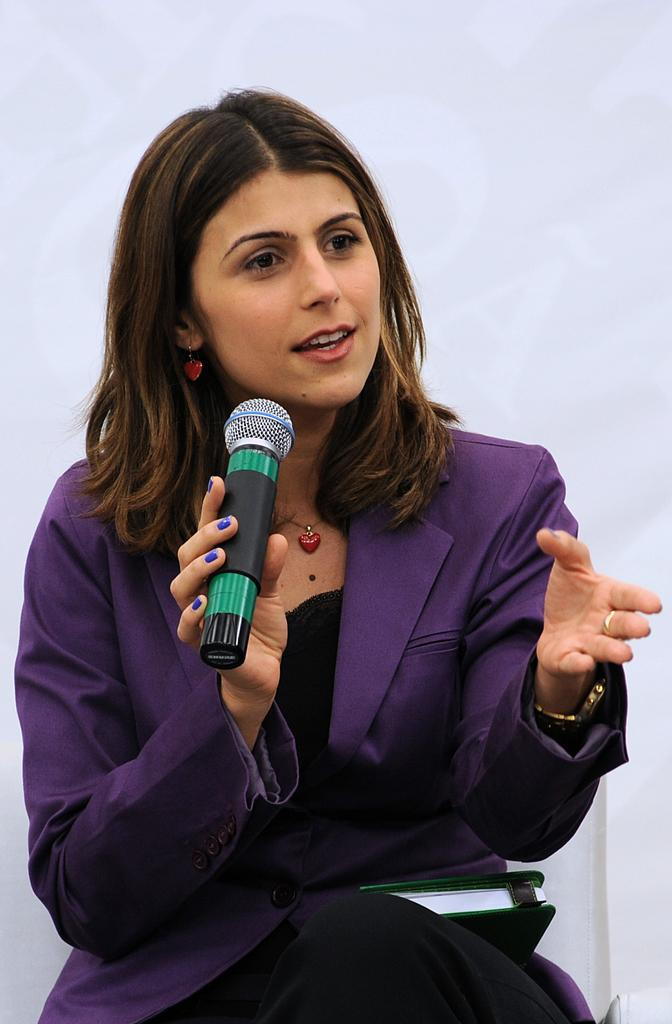Who is the main subject in the image? There is a woman in the image. What is the woman doing in the image? The woman is sitting in the image. What object is the woman holding in her hand? The woman is holding a mic in her hand. What is the name of the tooth that is visible in the image? There is no tooth visible in the image. How does the woman plan to increase her audience's engagement during her speech? The image does not provide information about the woman's plans for increasing audience engagement. 